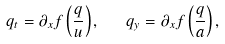<formula> <loc_0><loc_0><loc_500><loc_500>q _ { t } = \partial _ { x } f \left ( \frac { q } { u } \right ) , \text { \ \ } q _ { y } = \partial _ { x } f \left ( \frac { q } { a } \right ) ,</formula> 